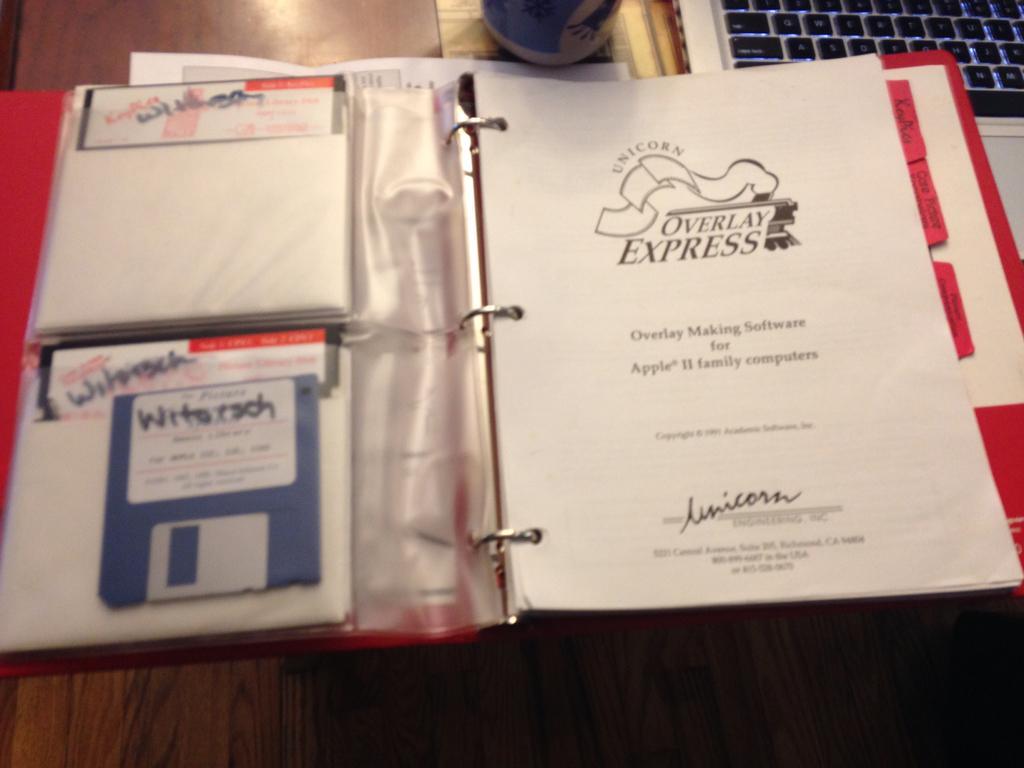Describe this image in one or two sentences. In this image I see a file over here and I see few papers on which there is something written and I see a floppy disk over here and I see the keyboard over here and all these things are on the brown color surface and I see a blue and white color thing over here. 